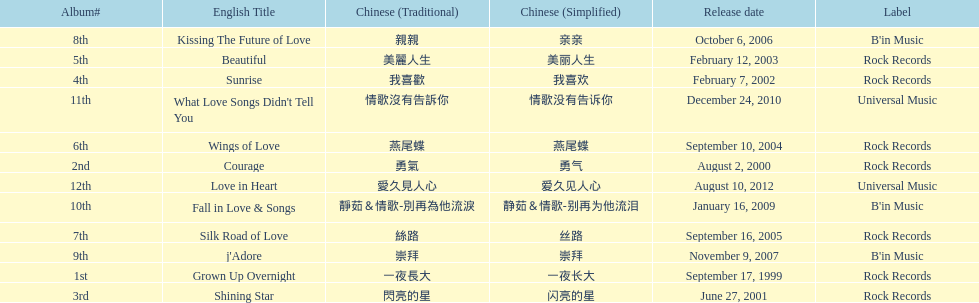What songs were on b'in music or universal music? Kissing The Future of Love, j'Adore, Fall in Love & Songs, What Love Songs Didn't Tell You, Love in Heart. 